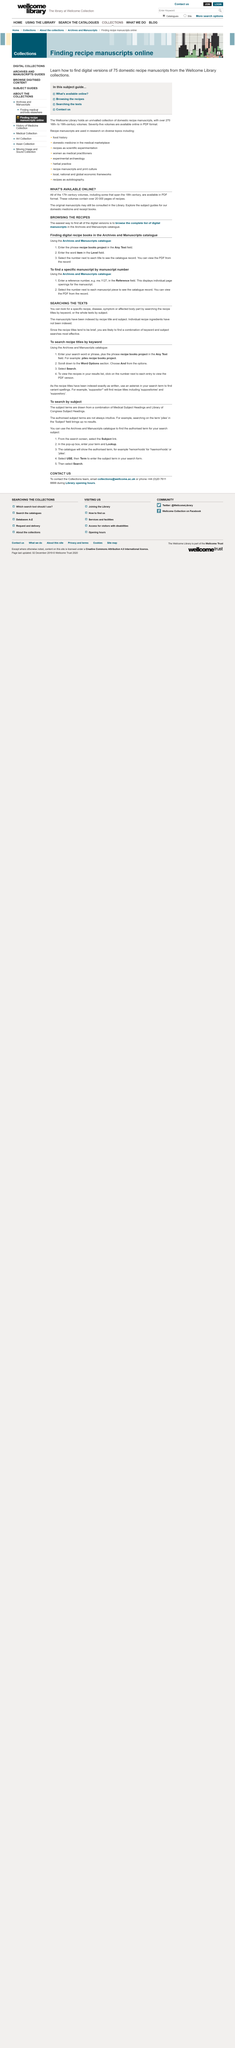Outline some significant characteristics in this image. The original manuscripts of the recipes can be found in the Library. The manuscripts have been indexed by recipe title and subject. The complete list of digital manuscripts can be found in the Archives and Manuscripts catalogue. A combination of keyword and subject is essential for effective searches. It has not been determined if the individual ingredients for each recipe have been indexed. 